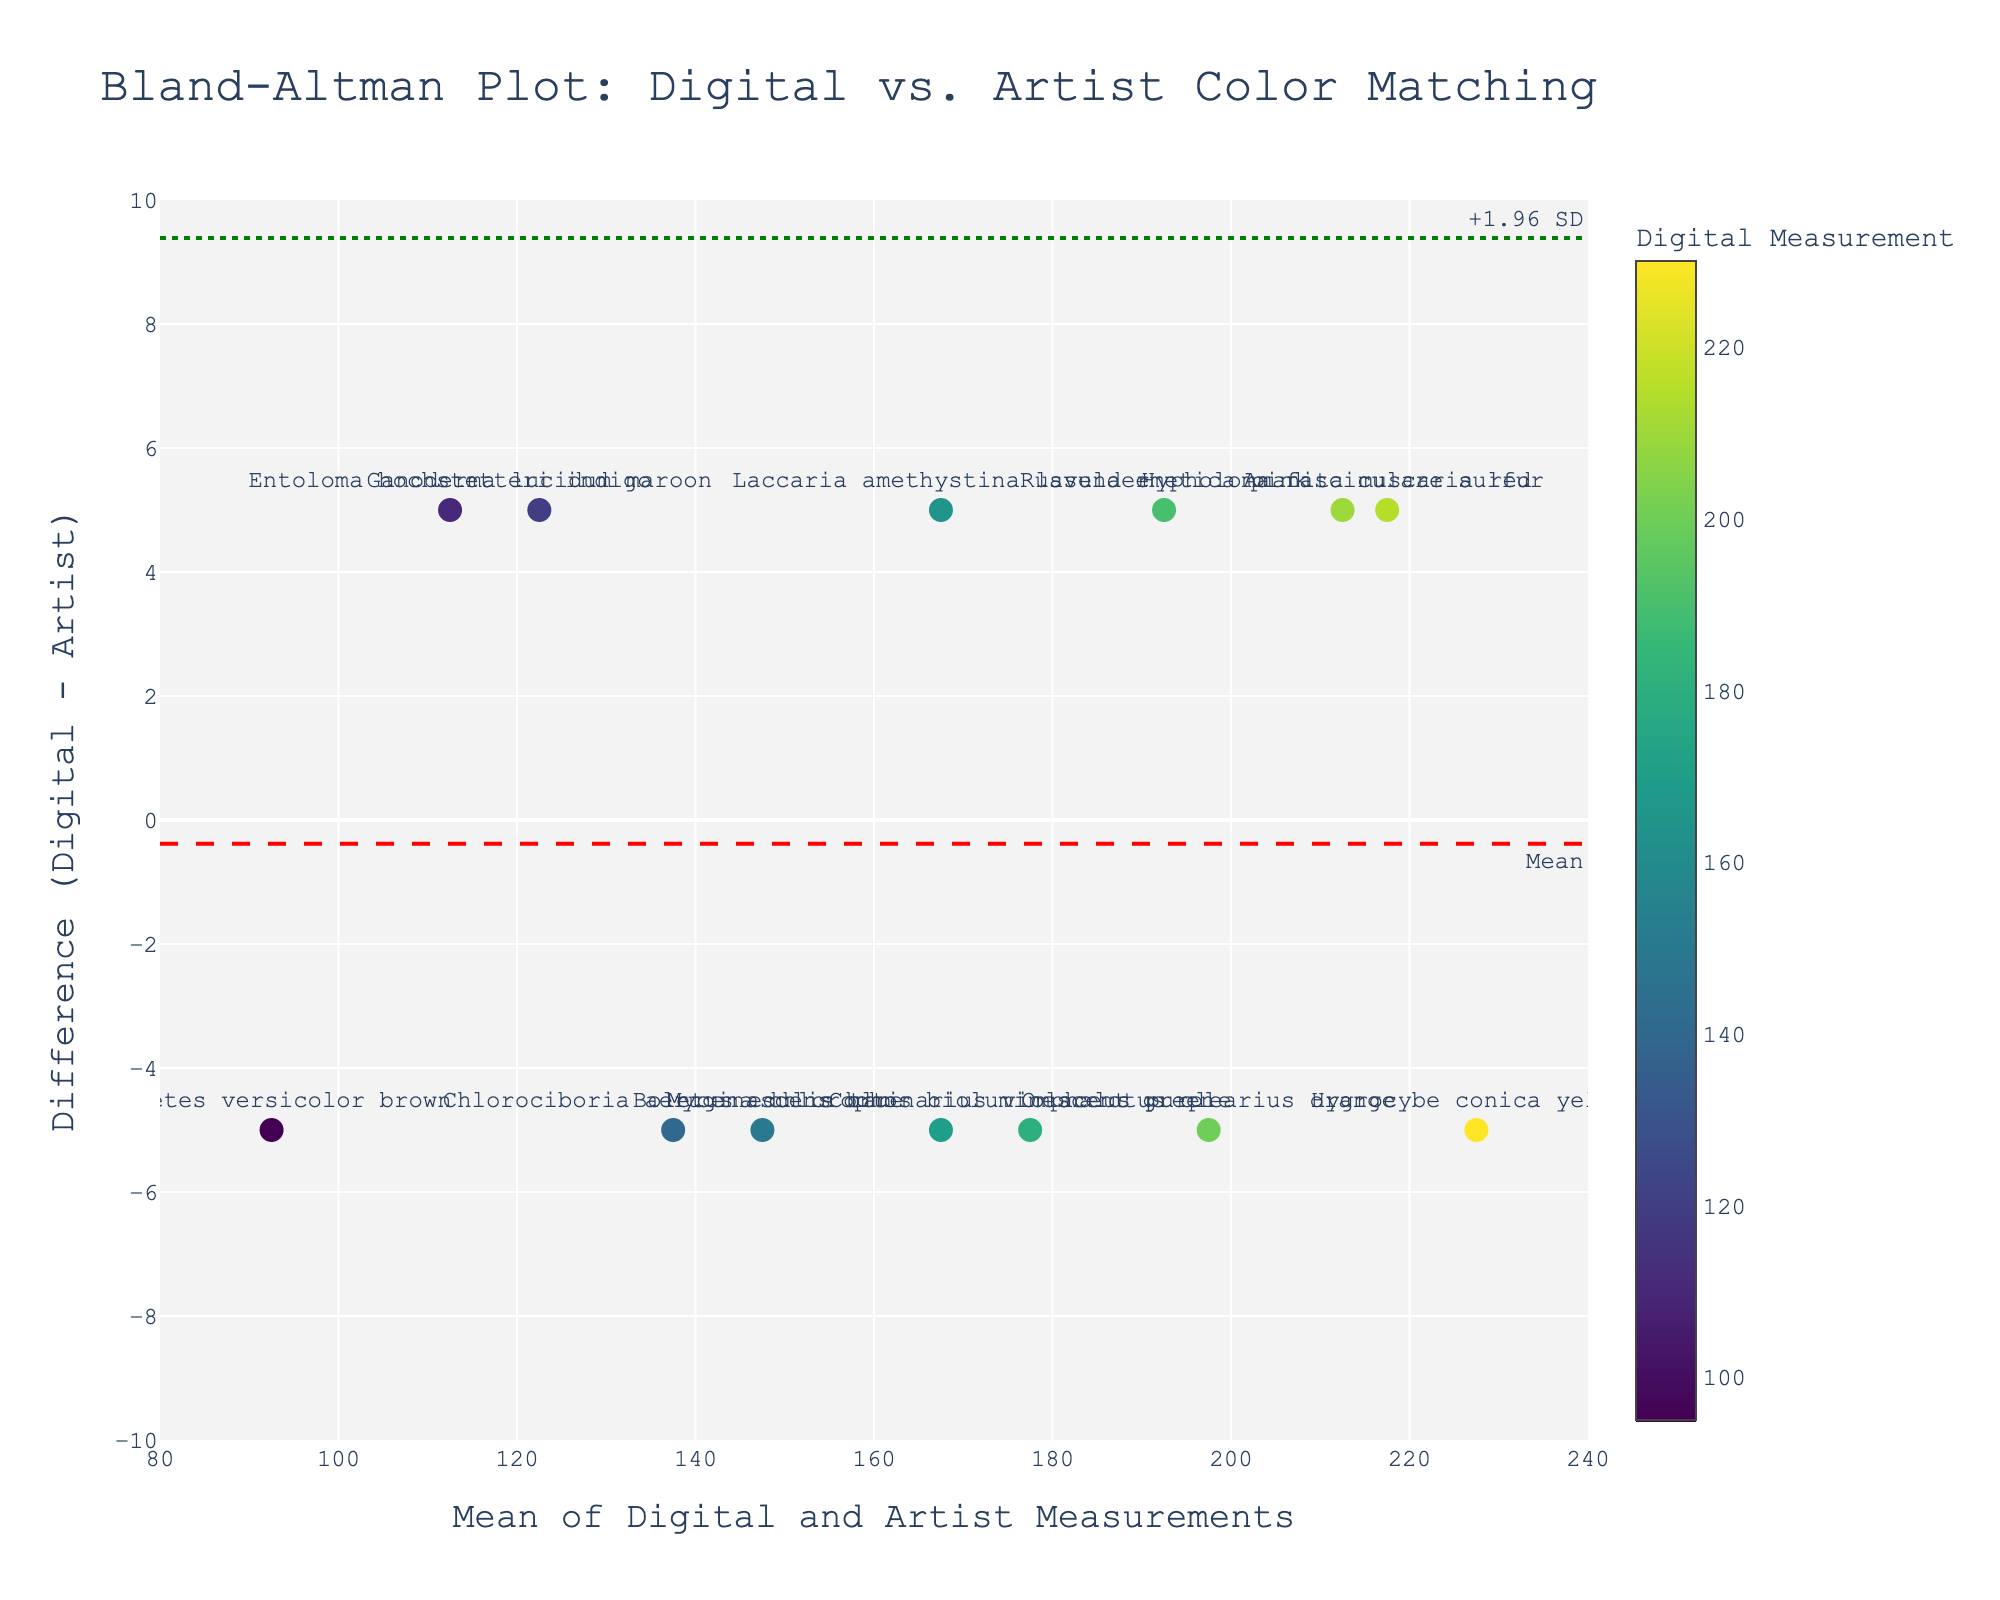What is the title of the plot? The title of the plot is prominently displayed at the top and reads "Bland-Altman Plot: Digital vs. Artist Color Matching".
Answer: Bland-Altman Plot: Digital vs. Artist Color Matching What do the y-axes represent in this plot? The y-axes represent the difference between the digital measurement and the artist matching for each mushroom-inspired palette.
Answer: Difference (Digital - Artist) How many data points are there in the plot? Each mushroom-inspired palette corresponds to one data point, and there are 13 different mushroom types listed, making 13 data points.
Answer: 13 Which mushroom color has the highest mean value of digital and artist measurements? By looking at the x-coordinates of the data points, the highest mean value corresponds to Hygrocybe conica yellow.
Answer: Hygrocybe conica yellow What is the value of the mean difference line (central dashed line)? The mean difference line is annotated with the label "Mean" at the bottom right of the plot, and it intersects the y-axis at 0.0.
Answer: 0.0 Which mushrooms have differences greater than 0? Points above the mean line (0 difference) have positive differences. These include Amanita muscaria red, Laccaria amethystina lavender, Hypholoma fasciculare sulfur, Ganoderma lucidum maroon, Russula emetica pink, and Entoloma hochstetteri indigo.
Answer: Amanita muscaria red, Laccaria amethystina lavender, Hypholoma fasciculare sulfur, Ganoderma lucidum maroon, Russula emetica pink, Entoloma hochstetteri indigo What color palette has the largest positive difference between digital measurements and artist matching? The largest positive difference is the highest point on the plot, labeled Amanita muscaria red, with a difference of 5.
Answer: Amanita muscaria red How many data points lie between the dashed and dotted green lines? The dashed red line represents the mean, and the dotted green lines represent ±1.96 SD. All data points fall within this range, which means 13 data points.
Answer: 13 What is the range of the x-axis in the plot? The range of the x-axis can be determined by the tick marks, which go from 80 to 240.
Answer: 80 to 240 Which color palette shows a digital measurement of approximately 200? Hovering over the points or interpreting the color scale, Omphalotus olearius orange shows a digital measurement of 200.
Answer: Omphalotus olearius orange 